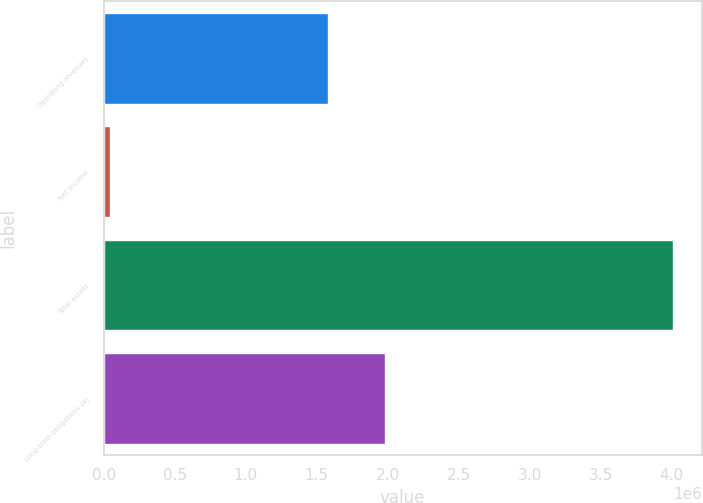Convert chart to OTSL. <chart><loc_0><loc_0><loc_500><loc_500><bar_chart><fcel>Operating revenues<fcel>Net income<fcel>Total assets<fcel>Long-term obligations (a)<nl><fcel>1.5815e+06<fcel>41971<fcel>4.01162e+06<fcel>1.97846e+06<nl></chart> 